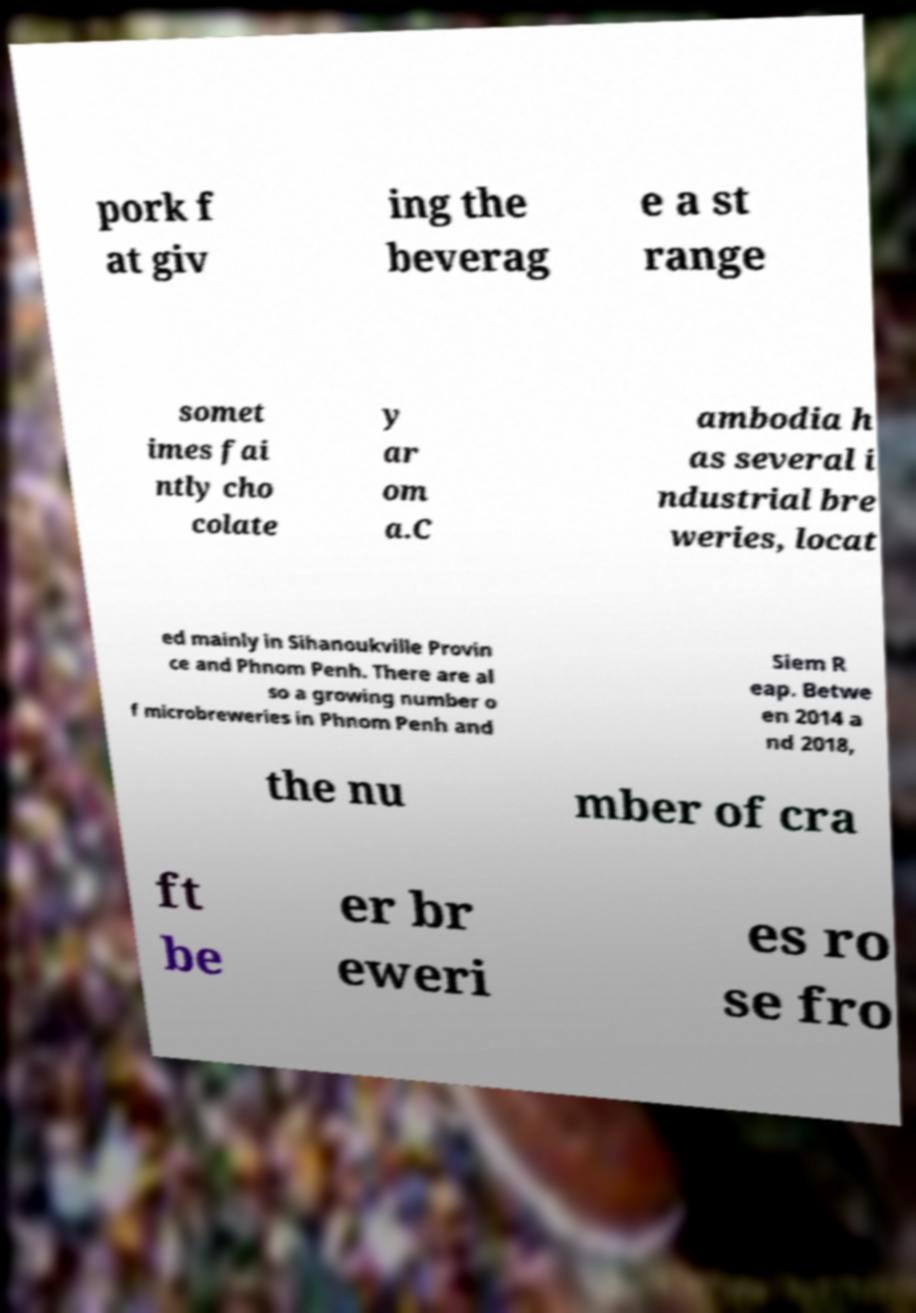Can you accurately transcribe the text from the provided image for me? pork f at giv ing the beverag e a st range somet imes fai ntly cho colate y ar om a.C ambodia h as several i ndustrial bre weries, locat ed mainly in Sihanoukville Provin ce and Phnom Penh. There are al so a growing number o f microbreweries in Phnom Penh and Siem R eap. Betwe en 2014 a nd 2018, the nu mber of cra ft be er br eweri es ro se fro 